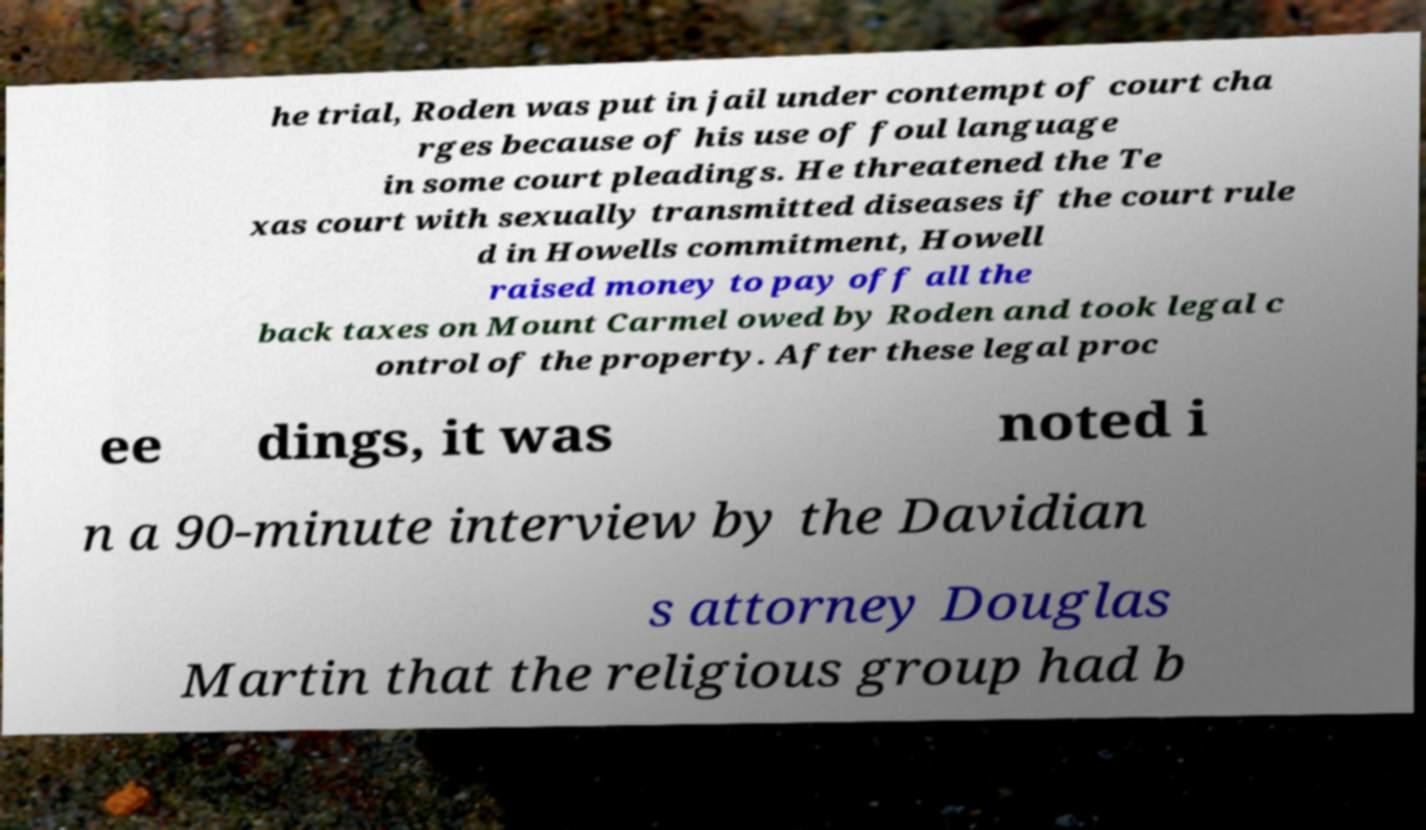Could you assist in decoding the text presented in this image and type it out clearly? he trial, Roden was put in jail under contempt of court cha rges because of his use of foul language in some court pleadings. He threatened the Te xas court with sexually transmitted diseases if the court rule d in Howells commitment, Howell raised money to pay off all the back taxes on Mount Carmel owed by Roden and took legal c ontrol of the property. After these legal proc ee dings, it was noted i n a 90-minute interview by the Davidian s attorney Douglas Martin that the religious group had b 